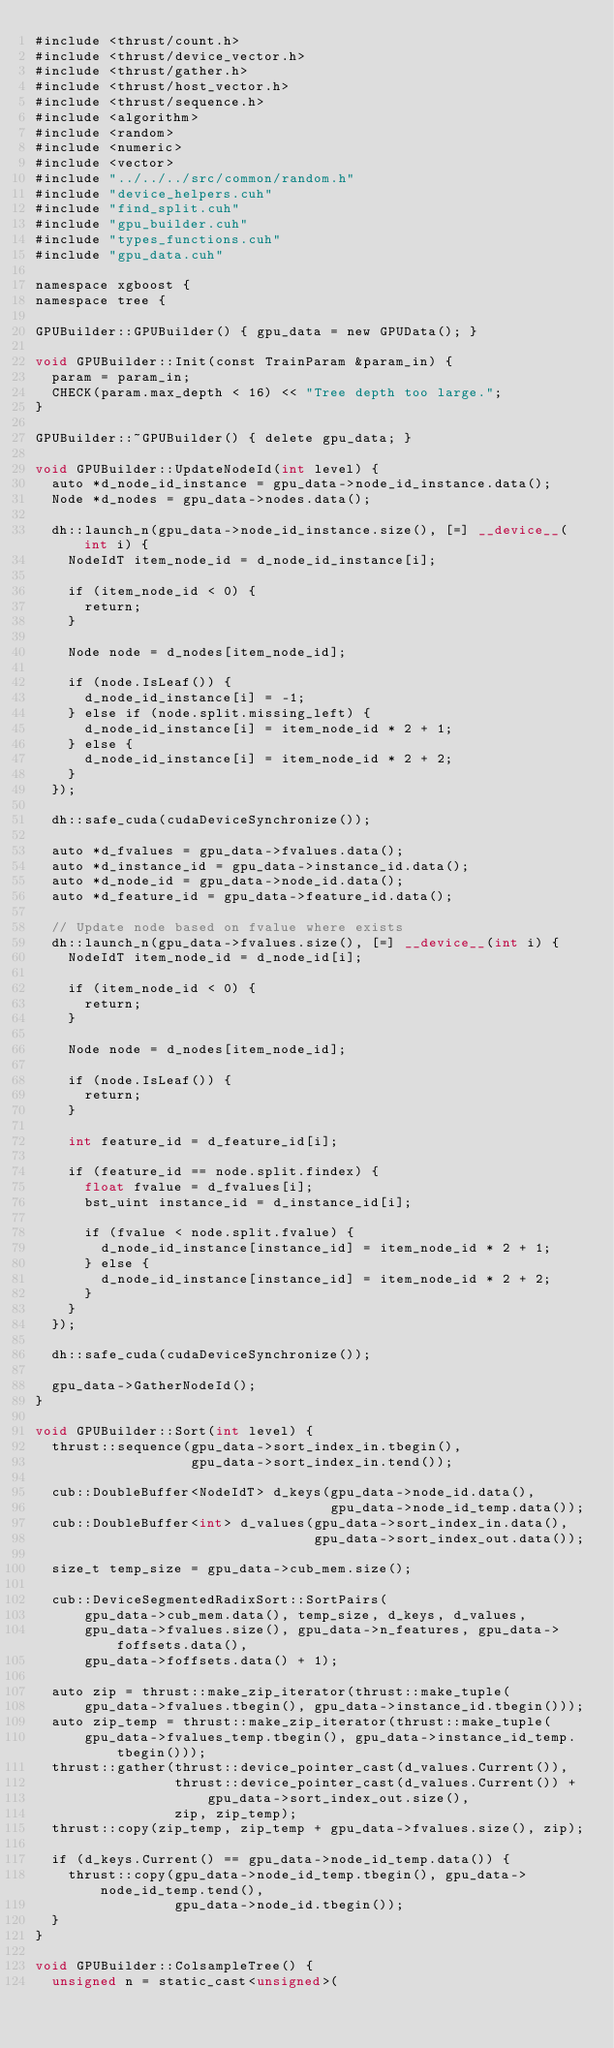<code> <loc_0><loc_0><loc_500><loc_500><_Cuda_>#include <thrust/count.h>
#include <thrust/device_vector.h>
#include <thrust/gather.h>
#include <thrust/host_vector.h>
#include <thrust/sequence.h>
#include <algorithm>
#include <random>
#include <numeric>
#include <vector>
#include "../../../src/common/random.h"
#include "device_helpers.cuh"
#include "find_split.cuh"
#include "gpu_builder.cuh"
#include "types_functions.cuh"
#include "gpu_data.cuh"

namespace xgboost {
namespace tree {

GPUBuilder::GPUBuilder() { gpu_data = new GPUData(); }

void GPUBuilder::Init(const TrainParam &param_in) {
  param = param_in;
  CHECK(param.max_depth < 16) << "Tree depth too large.";
}

GPUBuilder::~GPUBuilder() { delete gpu_data; }

void GPUBuilder::UpdateNodeId(int level) {
  auto *d_node_id_instance = gpu_data->node_id_instance.data();
  Node *d_nodes = gpu_data->nodes.data();

  dh::launch_n(gpu_data->node_id_instance.size(), [=] __device__(int i) {
    NodeIdT item_node_id = d_node_id_instance[i];

    if (item_node_id < 0) {
      return;
    }

    Node node = d_nodes[item_node_id];

    if (node.IsLeaf()) {
      d_node_id_instance[i] = -1;
    } else if (node.split.missing_left) {
      d_node_id_instance[i] = item_node_id * 2 + 1;
    } else {
      d_node_id_instance[i] = item_node_id * 2 + 2;
    }
  });

  dh::safe_cuda(cudaDeviceSynchronize());

  auto *d_fvalues = gpu_data->fvalues.data();
  auto *d_instance_id = gpu_data->instance_id.data();
  auto *d_node_id = gpu_data->node_id.data();
  auto *d_feature_id = gpu_data->feature_id.data();

  // Update node based on fvalue where exists
  dh::launch_n(gpu_data->fvalues.size(), [=] __device__(int i) {
    NodeIdT item_node_id = d_node_id[i];

    if (item_node_id < 0) {
      return;
    }

    Node node = d_nodes[item_node_id];

    if (node.IsLeaf()) {
      return;
    }

    int feature_id = d_feature_id[i];

    if (feature_id == node.split.findex) {
      float fvalue = d_fvalues[i];
      bst_uint instance_id = d_instance_id[i];

      if (fvalue < node.split.fvalue) {
        d_node_id_instance[instance_id] = item_node_id * 2 + 1;
      } else {
        d_node_id_instance[instance_id] = item_node_id * 2 + 2;
      }
    }
  });

  dh::safe_cuda(cudaDeviceSynchronize());

  gpu_data->GatherNodeId();
}

void GPUBuilder::Sort(int level) {
  thrust::sequence(gpu_data->sort_index_in.tbegin(),
                   gpu_data->sort_index_in.tend());

  cub::DoubleBuffer<NodeIdT> d_keys(gpu_data->node_id.data(),
                                    gpu_data->node_id_temp.data());
  cub::DoubleBuffer<int> d_values(gpu_data->sort_index_in.data(),
                                  gpu_data->sort_index_out.data());

  size_t temp_size = gpu_data->cub_mem.size();

  cub::DeviceSegmentedRadixSort::SortPairs(
      gpu_data->cub_mem.data(), temp_size, d_keys, d_values,
      gpu_data->fvalues.size(), gpu_data->n_features, gpu_data->foffsets.data(),
      gpu_data->foffsets.data() + 1);

  auto zip = thrust::make_zip_iterator(thrust::make_tuple(
      gpu_data->fvalues.tbegin(), gpu_data->instance_id.tbegin()));
  auto zip_temp = thrust::make_zip_iterator(thrust::make_tuple(
      gpu_data->fvalues_temp.tbegin(), gpu_data->instance_id_temp.tbegin()));
  thrust::gather(thrust::device_pointer_cast(d_values.Current()),
                 thrust::device_pointer_cast(d_values.Current()) +
                     gpu_data->sort_index_out.size(),
                 zip, zip_temp);
  thrust::copy(zip_temp, zip_temp + gpu_data->fvalues.size(), zip);

  if (d_keys.Current() == gpu_data->node_id_temp.data()) {
    thrust::copy(gpu_data->node_id_temp.tbegin(), gpu_data->node_id_temp.tend(),
                 gpu_data->node_id.tbegin());
  }
}

void GPUBuilder::ColsampleTree() {
  unsigned n = static_cast<unsigned>(</code> 